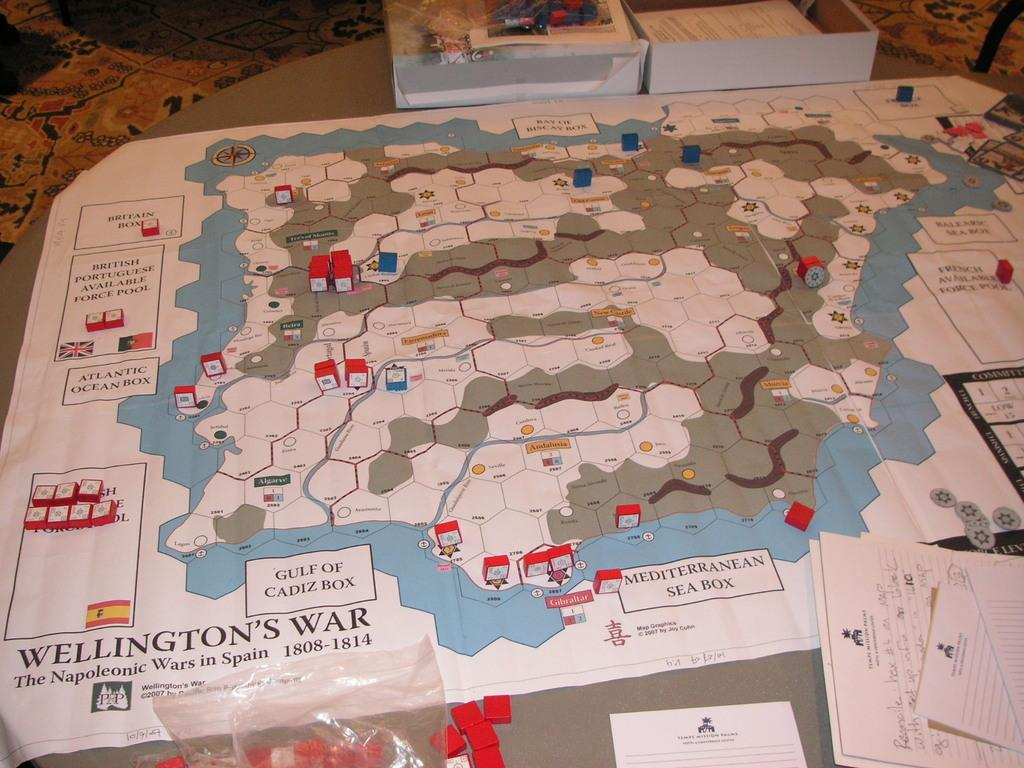<image>
Give a short and clear explanation of the subsequent image. a map of Wellington's War game laid out on a carpet 